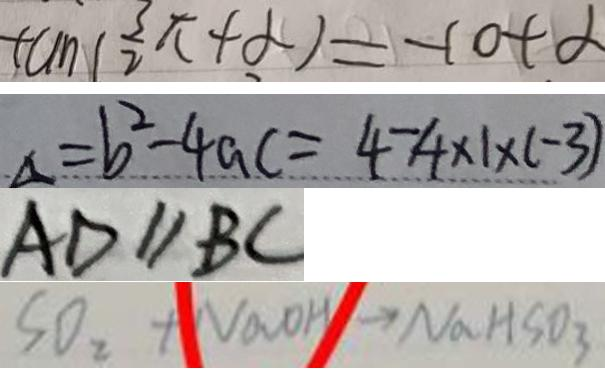Convert formula to latex. <formula><loc_0><loc_0><loc_500><loc_500>\tan ( \frac { 3 \pi } { 2 } + \alpha ) = - \cot \alpha 
 a = b ^ { 2 } - 4 a c = 4 - 4 \times 1 \times ( - 3 ) 
 A D / / B C 
 S O _ { 2 } + N a O H \rightarrow N a H S O _ { 3 }</formula> 